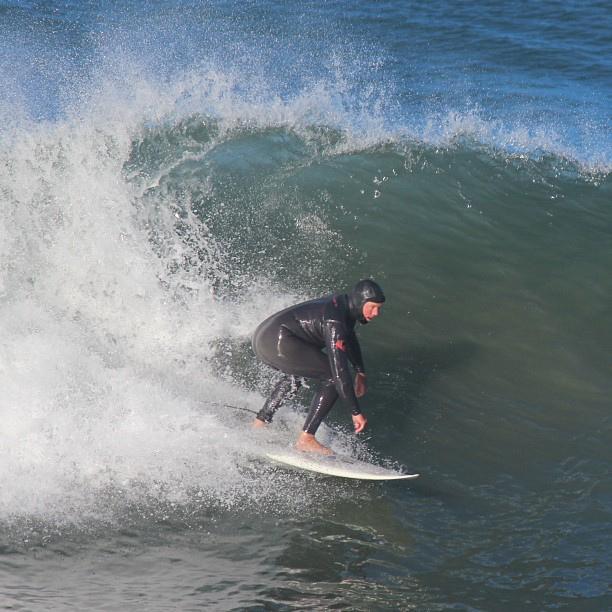What size is the wave?
Give a very brief answer. Large. Does the wetsuit cover his head?
Give a very brief answer. Yes. What is the man doing?
Quick response, please. Surfing. Is his suit wet?
Keep it brief. Yes. 